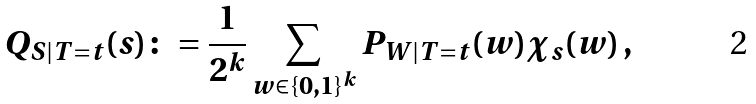Convert formula to latex. <formula><loc_0><loc_0><loc_500><loc_500>Q _ { S | T = t } ( s ) \colon = \frac { 1 } { 2 ^ { k } } \sum _ { w \in \{ 0 , 1 \} ^ { k } } P _ { W | T = t } ( w ) \chi _ { s } ( w ) \, ,</formula> 